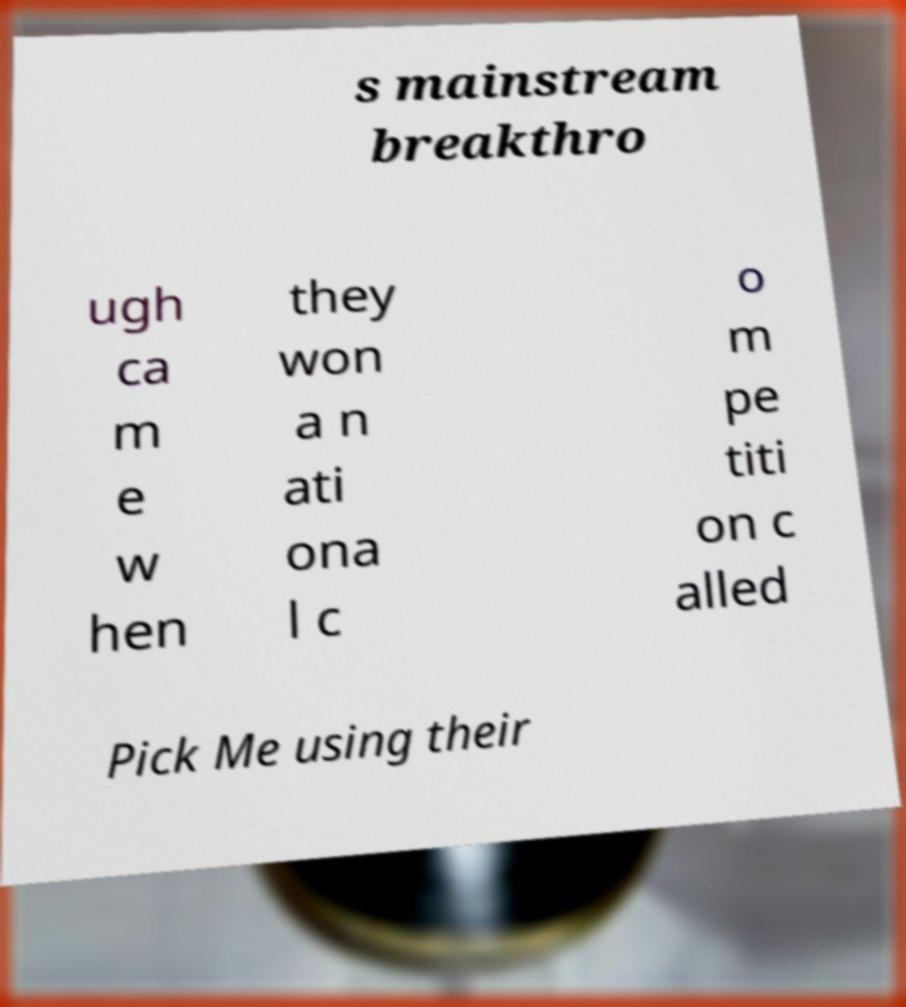There's text embedded in this image that I need extracted. Can you transcribe it verbatim? s mainstream breakthro ugh ca m e w hen they won a n ati ona l c o m pe titi on c alled Pick Me using their 